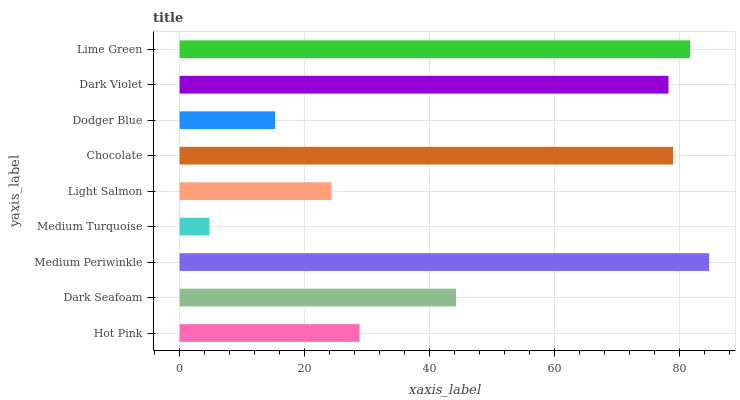Is Medium Turquoise the minimum?
Answer yes or no. Yes. Is Medium Periwinkle the maximum?
Answer yes or no. Yes. Is Dark Seafoam the minimum?
Answer yes or no. No. Is Dark Seafoam the maximum?
Answer yes or no. No. Is Dark Seafoam greater than Hot Pink?
Answer yes or no. Yes. Is Hot Pink less than Dark Seafoam?
Answer yes or no. Yes. Is Hot Pink greater than Dark Seafoam?
Answer yes or no. No. Is Dark Seafoam less than Hot Pink?
Answer yes or no. No. Is Dark Seafoam the high median?
Answer yes or no. Yes. Is Dark Seafoam the low median?
Answer yes or no. Yes. Is Medium Periwinkle the high median?
Answer yes or no. No. Is Medium Turquoise the low median?
Answer yes or no. No. 